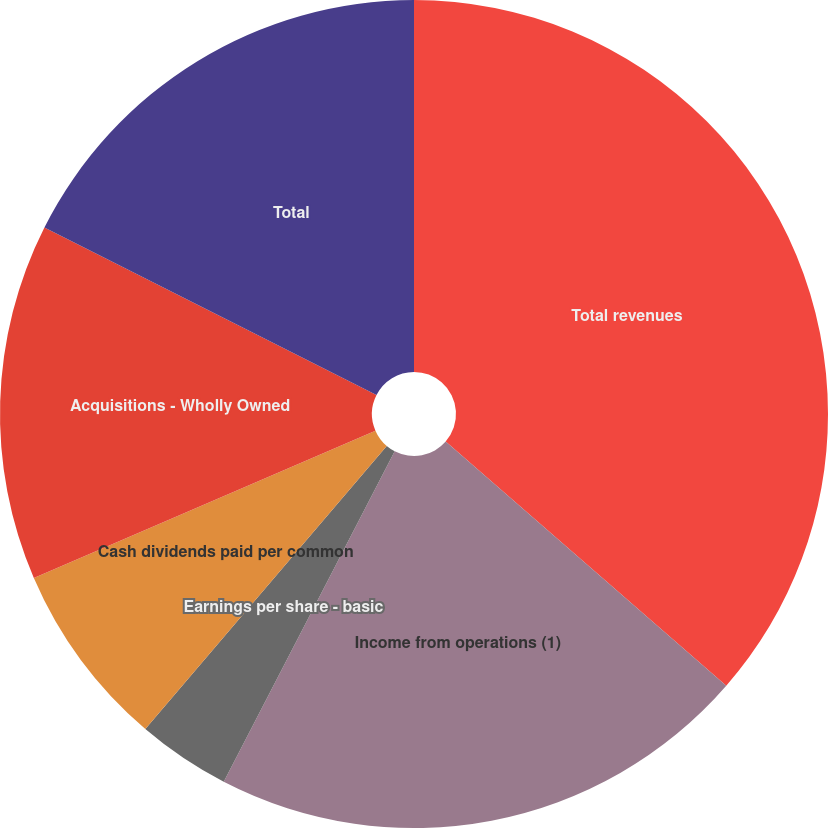<chart> <loc_0><loc_0><loc_500><loc_500><pie_chart><fcel>Total revenues<fcel>Income from operations (1)<fcel>Earnings per share - basic<fcel>Earnings per share - diluted<fcel>Cash dividends paid per common<fcel>Acquisitions - Wholly Owned<fcel>Total<nl><fcel>36.4%<fcel>21.2%<fcel>3.64%<fcel>0.0%<fcel>7.28%<fcel>13.92%<fcel>17.56%<nl></chart> 